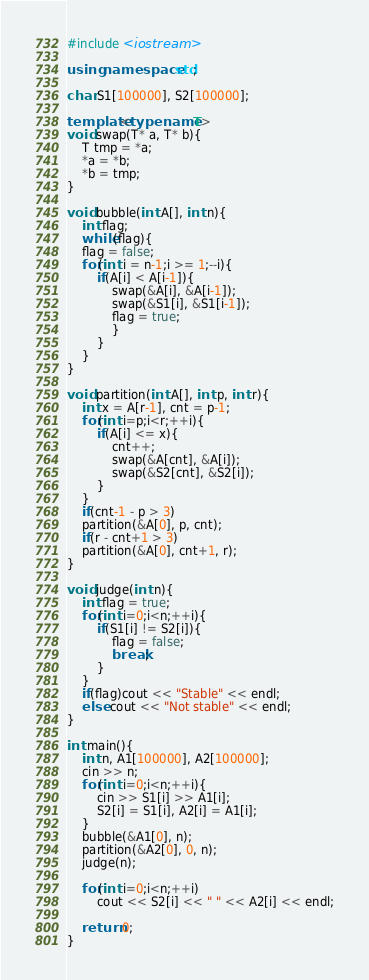Convert code to text. <code><loc_0><loc_0><loc_500><loc_500><_C++_>#include <iostream>

using namespace std;

char S1[100000], S2[100000];

template<typename T>
void swap(T* a, T* b){
	T tmp = *a;
	*a = *b;
	*b = tmp;
}

void bubble(int A[], int n){
	int flag;
	while(flag){
	flag = false;
	for(int i = n-1;i >= 1;--i){
		if(A[i] < A[i-1]){
			swap(&A[i], &A[i-1]);
			swap(&S1[i], &S1[i-1]);
			flag = true;
			}
		}
	}
}

void partition(int A[], int p, int r){
	int x = A[r-1], cnt = p-1;
	for(int i=p;i<r;++i){
		if(A[i] <= x){
			cnt++;
			swap(&A[cnt], &A[i]);
			swap(&S2[cnt], &S2[i]);
		}
	}
	if(cnt-1 - p > 3)
	partition(&A[0], p, cnt);
	if(r - cnt+1 > 3)
	partition(&A[0], cnt+1, r);
}

void judge(int n){
	int flag = true;
	for(int i=0;i<n;++i){
		if(S1[i] != S2[i]){
			flag = false;
			break;
		}
	}
	if(flag)cout << "Stable" << endl;
	else cout << "Not stable" << endl;
}

int main(){
	int n, A1[100000], A2[100000];
	cin >> n;
	for(int i=0;i<n;++i){
		cin >> S1[i] >> A1[i];
		S2[i] = S1[i], A2[i] = A1[i];
	}
	bubble(&A1[0], n);
	partition(&A2[0], 0, n);
	judge(n);
	
	for(int i=0;i<n;++i)
		cout << S2[i] << " " << A2[i] << endl;
	
	return 0;
}
</code> 